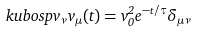<formula> <loc_0><loc_0><loc_500><loc_500>\ k u b o s p { v _ { \nu } } { v _ { \mu } ( t ) } = v _ { 0 } ^ { 2 } e ^ { - t / \tau } \delta _ { \mu \nu } \,</formula> 